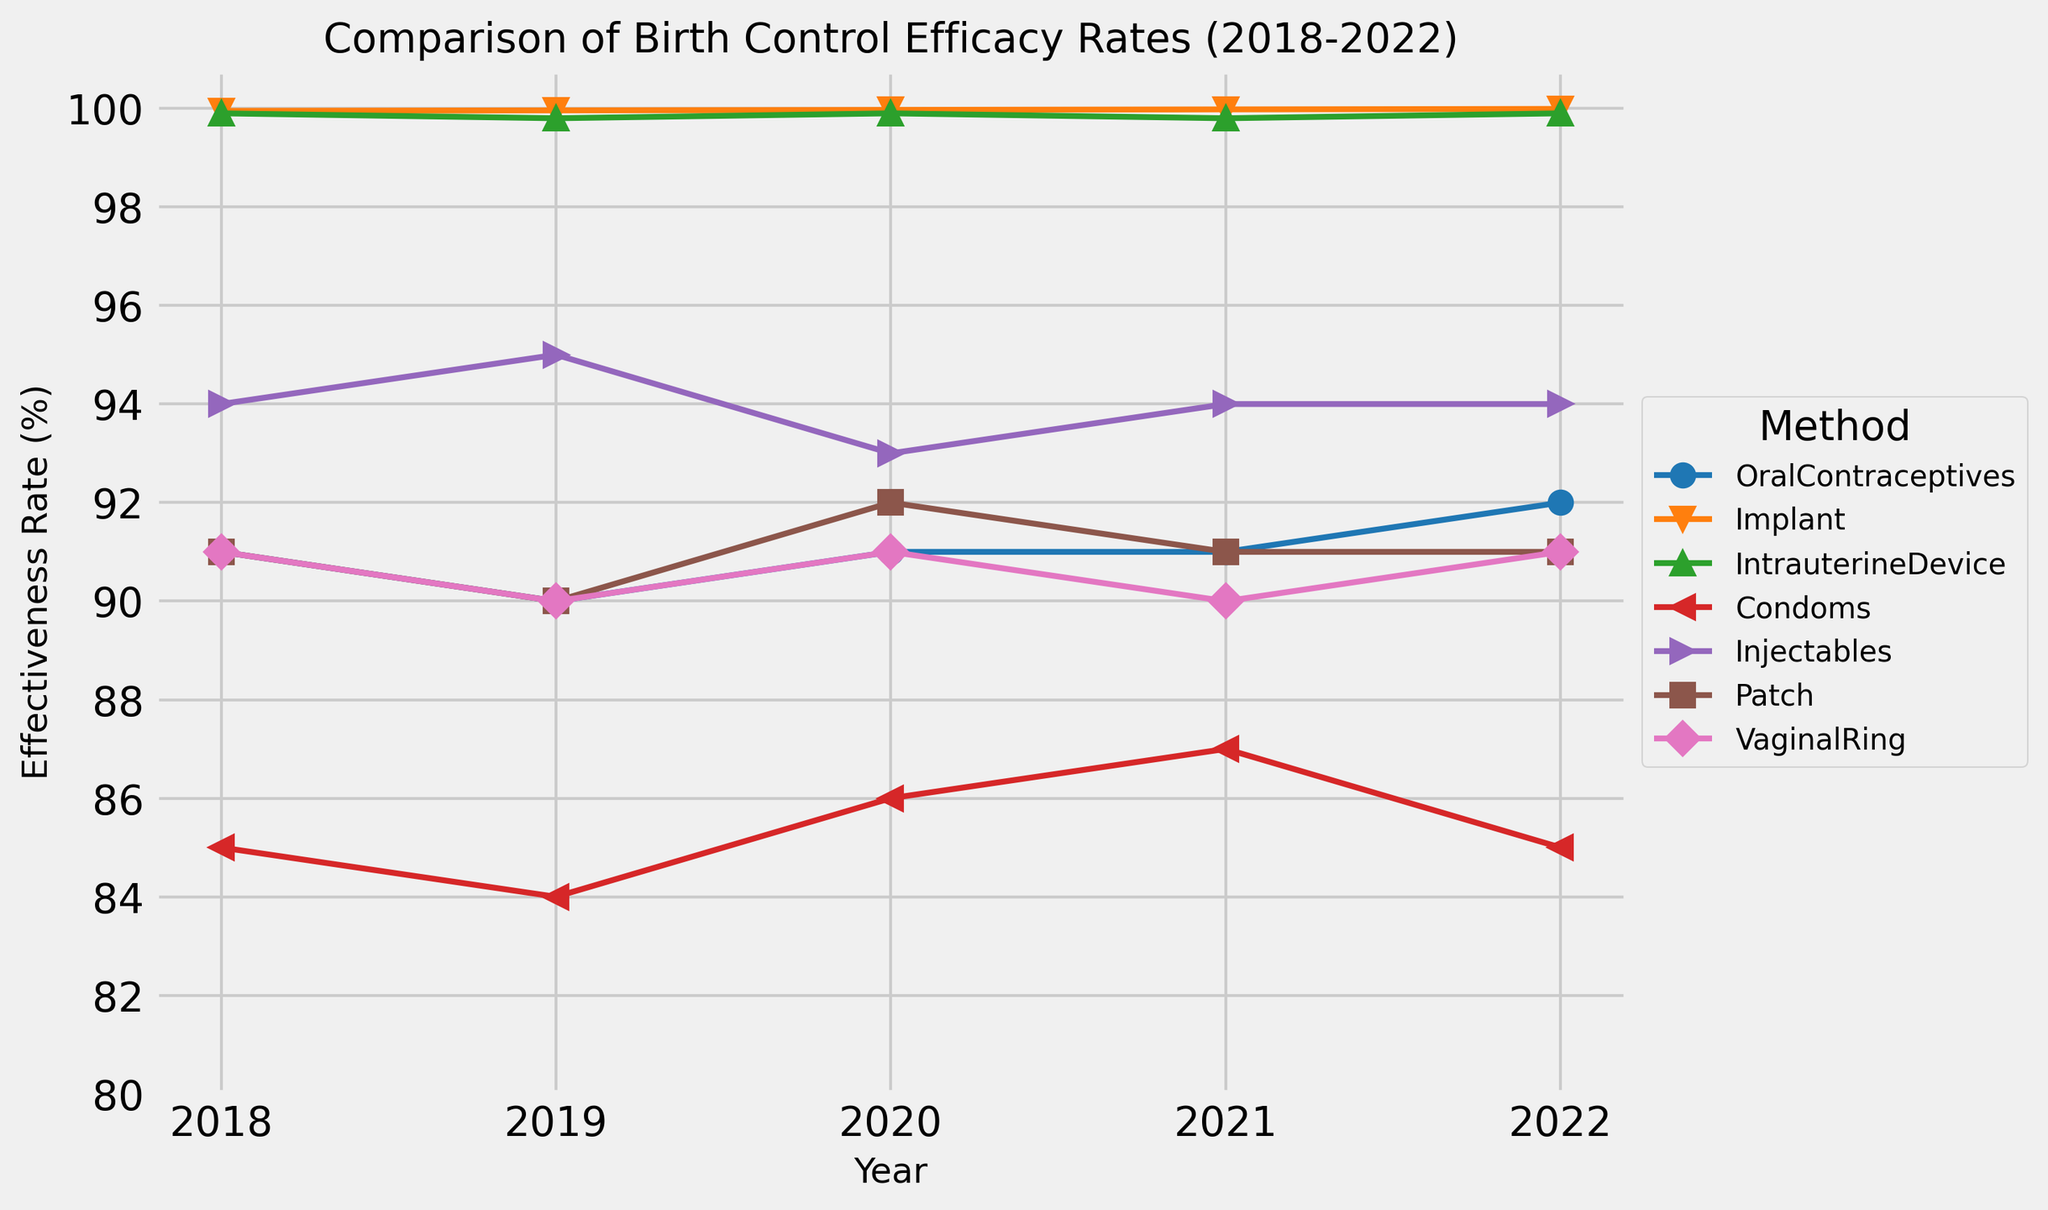Which birth control method had the highest effectiveness rate in 2020? Look for the highest point in the year 2020 on the chart. The implant method shows the highest effectiveness rate.
Answer: Implant What was the trend in the effectiveness rate of condoms from 2018 to 2022? Track the line for condoms (red color) from 2018 to 2022. The effectiveness rate fluctuated: starting at 85% in 2018, dropping to 84% in 2019, rising to 86% in 2020, climbing to 87% in 2021, and then falling to 85% in 2022.
Answer: Fluctuated How did the effectiveness rate of the patch change between 2019 and 2020? Observe the line for the patch (brown color) between 2019 and 2020. The rate increased from 90% in 2019 to 92% in 2020.
Answer: Increased Which two methods maintained a constant effectiveness rate of at least 99.9% throughout the period 2018-2022? Identify the lines that never fall below 99.9 across all years. Both the implant (orange) and the intrauterine device (green) maintained this rate.
Answer: Implant, IntrauterineDevice What was the difference in effectiveness rates between oral contraceptives and injectables in 2019? Look at the points for oral contraceptives (blue) and injectables (purple) in 2019. Oral contraceptives had a rate of 90% and injectables had 95%, the difference is 95% - 90% = 5%.
Answer: 5% What year did vaginal rings experience the lowest effectiveness rate, and what was that rate? Scan the line for vaginal rings (pink) to find the lowest point. The lowest rate occurs in 2019 and 2021, both at 90%.
Answer: 2019 and 2021, 90% On average, how did the effectiveness rate of oral contraceptives change from 2018 to 2022? Calculate the average rate for oral contraceptives over the years: (91 + 90 + 91 + 91 + 92) / 5 = 91%.
Answer: 91% Which method showed the steadiest effectiveness rate over the 5 years? Look for the line that shows the least fluctuation. The implant (orange) has very steady rates with slight increases each year.
Answer: Implant If you sum the effectiveness rates for intrauterine devices for all 5 years, what is the total? Add up the yearly effectiveness rates for intrauterine devices (green): 99.9 + 99.8 + 99.9 + 99.8 + 99.9 = 499.3.
Answer: 499.3 Was the effectiveness rate for injectables higher or lower in 2021 compared to 2020? Compare the points for injectables (purple) in 2020 and 2021. The rate in 2020 was 93% and in 2021 it was 94%, so it was higher in 2021.
Answer: Higher 